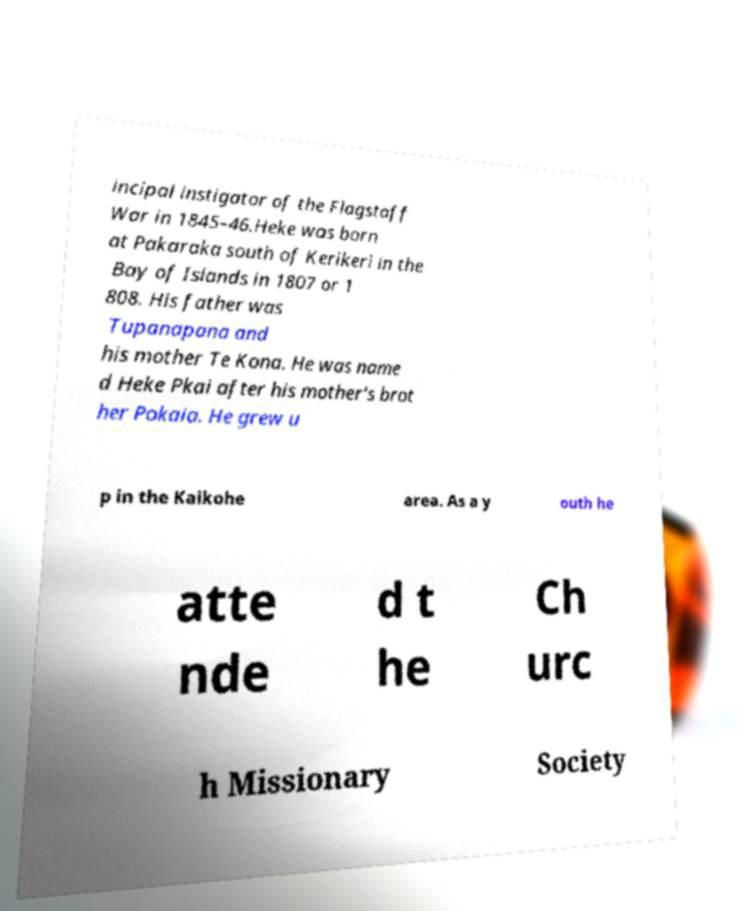Could you extract and type out the text from this image? incipal instigator of the Flagstaff War in 1845–46.Heke was born at Pakaraka south of Kerikeri in the Bay of Islands in 1807 or 1 808. His father was Tupanapana and his mother Te Kona. He was name d Heke Pkai after his mother's brot her Pokaia. He grew u p in the Kaikohe area. As a y outh he atte nde d t he Ch urc h Missionary Society 